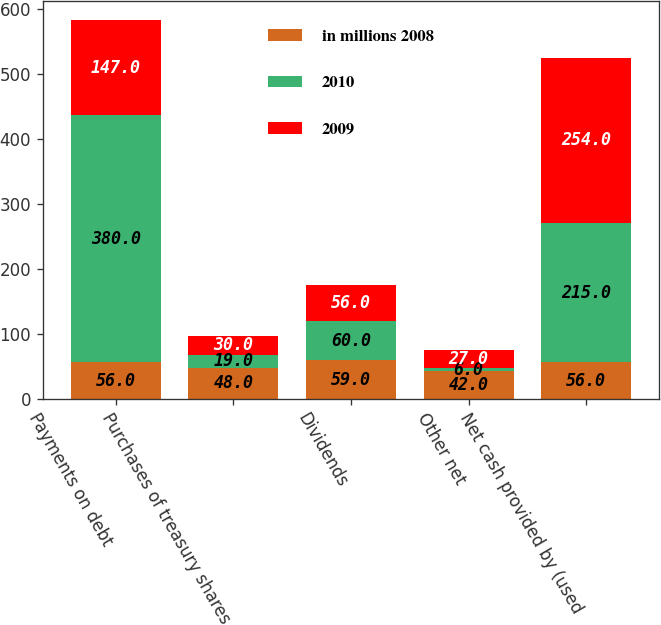Convert chart to OTSL. <chart><loc_0><loc_0><loc_500><loc_500><stacked_bar_chart><ecel><fcel>Payments on debt<fcel>Purchases of treasury shares<fcel>Dividends<fcel>Other net<fcel>Net cash provided by (used<nl><fcel>in millions 2008<fcel>56<fcel>48<fcel>59<fcel>42<fcel>56<nl><fcel>2010<fcel>380<fcel>19<fcel>60<fcel>6<fcel>215<nl><fcel>2009<fcel>147<fcel>30<fcel>56<fcel>27<fcel>254<nl></chart> 